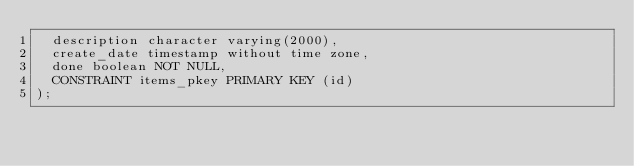Convert code to text. <code><loc_0><loc_0><loc_500><loc_500><_SQL_>  description character varying(2000),
  create_date timestamp without time zone,
  done boolean NOT NULL,
  CONSTRAINT items_pkey PRIMARY KEY (id)
);
</code> 